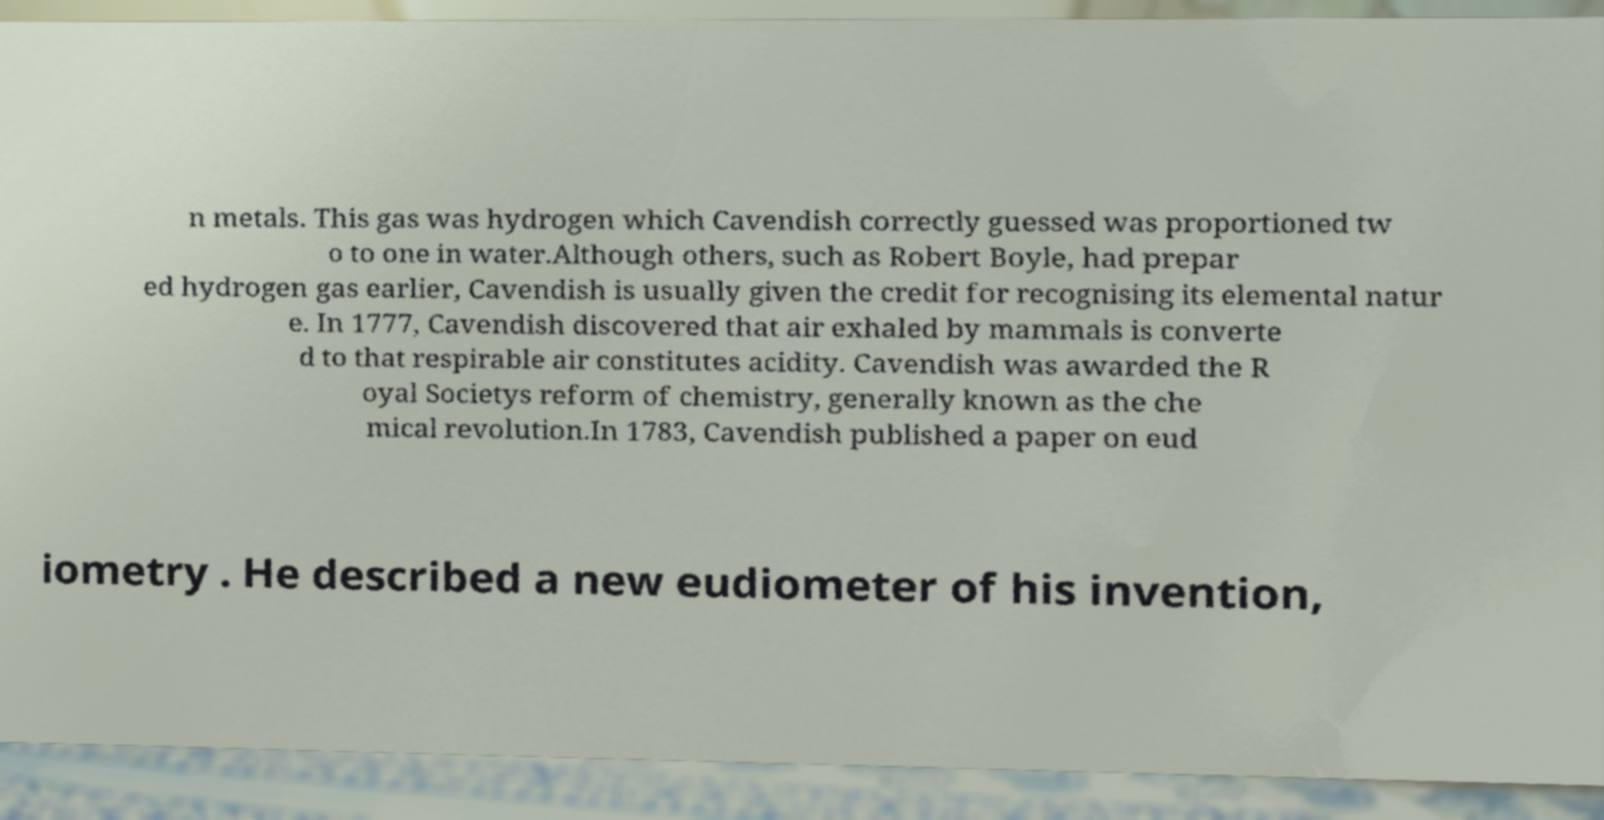Can you accurately transcribe the text from the provided image for me? n metals. This gas was hydrogen which Cavendish correctly guessed was proportioned tw o to one in water.Although others, such as Robert Boyle, had prepar ed hydrogen gas earlier, Cavendish is usually given the credit for recognising its elemental natur e. In 1777, Cavendish discovered that air exhaled by mammals is converte d to that respirable air constitutes acidity. Cavendish was awarded the R oyal Societys reform of chemistry, generally known as the che mical revolution.In 1783, Cavendish published a paper on eud iometry . He described a new eudiometer of his invention, 